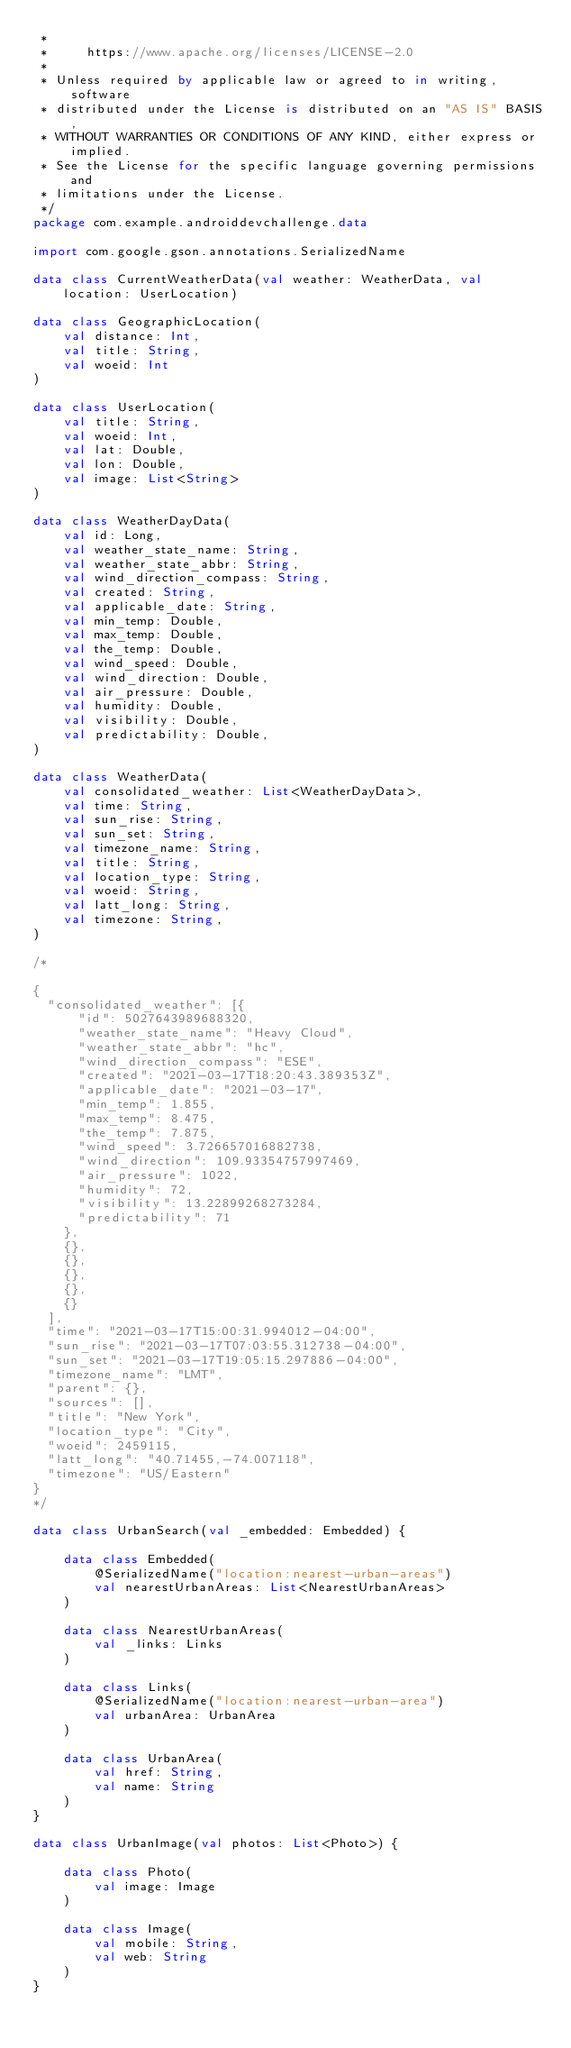Convert code to text. <code><loc_0><loc_0><loc_500><loc_500><_Kotlin_> *
 *     https://www.apache.org/licenses/LICENSE-2.0
 *
 * Unless required by applicable law or agreed to in writing, software
 * distributed under the License is distributed on an "AS IS" BASIS,
 * WITHOUT WARRANTIES OR CONDITIONS OF ANY KIND, either express or implied.
 * See the License for the specific language governing permissions and
 * limitations under the License.
 */
package com.example.androiddevchallenge.data

import com.google.gson.annotations.SerializedName

data class CurrentWeatherData(val weather: WeatherData, val location: UserLocation)

data class GeographicLocation(
    val distance: Int,
    val title: String,
    val woeid: Int
)

data class UserLocation(
    val title: String,
    val woeid: Int,
    val lat: Double,
    val lon: Double,
    val image: List<String>
)

data class WeatherDayData(
    val id: Long,
    val weather_state_name: String,
    val weather_state_abbr: String,
    val wind_direction_compass: String,
    val created: String,
    val applicable_date: String,
    val min_temp: Double,
    val max_temp: Double,
    val the_temp: Double,
    val wind_speed: Double,
    val wind_direction: Double,
    val air_pressure: Double,
    val humidity: Double,
    val visibility: Double,
    val predictability: Double,
)

data class WeatherData(
    val consolidated_weather: List<WeatherDayData>,
    val time: String,
    val sun_rise: String,
    val sun_set: String,
    val timezone_name: String,
    val title: String,
    val location_type: String,
    val woeid: String,
    val latt_long: String,
    val timezone: String,
)

/*

{
	"consolidated_weather": [{
			"id": 5027643989688320,
			"weather_state_name": "Heavy Cloud",
			"weather_state_abbr": "hc",
			"wind_direction_compass": "ESE",
			"created": "2021-03-17T18:20:43.389353Z",
			"applicable_date": "2021-03-17",
			"min_temp": 1.855,
			"max_temp": 8.475,
			"the_temp": 7.875,
			"wind_speed": 3.726657016882738,
			"wind_direction": 109.93354757997469,
			"air_pressure": 1022,
			"humidity": 72,
			"visibility": 13.22899268273284,
			"predictability": 71
		},
		{},
		{},
		{},
		{},
		{}
	],
	"time": "2021-03-17T15:00:31.994012-04:00",
	"sun_rise": "2021-03-17T07:03:55.312738-04:00",
	"sun_set": "2021-03-17T19:05:15.297886-04:00",
	"timezone_name": "LMT",
	"parent": {},
	"sources": [],
	"title": "New York",
	"location_type": "City",
	"woeid": 2459115,
	"latt_long": "40.71455,-74.007118",
	"timezone": "US/Eastern"
}
*/

data class UrbanSearch(val _embedded: Embedded) {

    data class Embedded(
        @SerializedName("location:nearest-urban-areas")
        val nearestUrbanAreas: List<NearestUrbanAreas>
    )

    data class NearestUrbanAreas(
        val _links: Links
    )

    data class Links(
        @SerializedName("location:nearest-urban-area")
        val urbanArea: UrbanArea
    )

    data class UrbanArea(
        val href: String,
        val name: String
    )
}

data class UrbanImage(val photos: List<Photo>) {

    data class Photo(
        val image: Image
    )

    data class Image(
        val mobile: String,
        val web: String
    )
}
</code> 